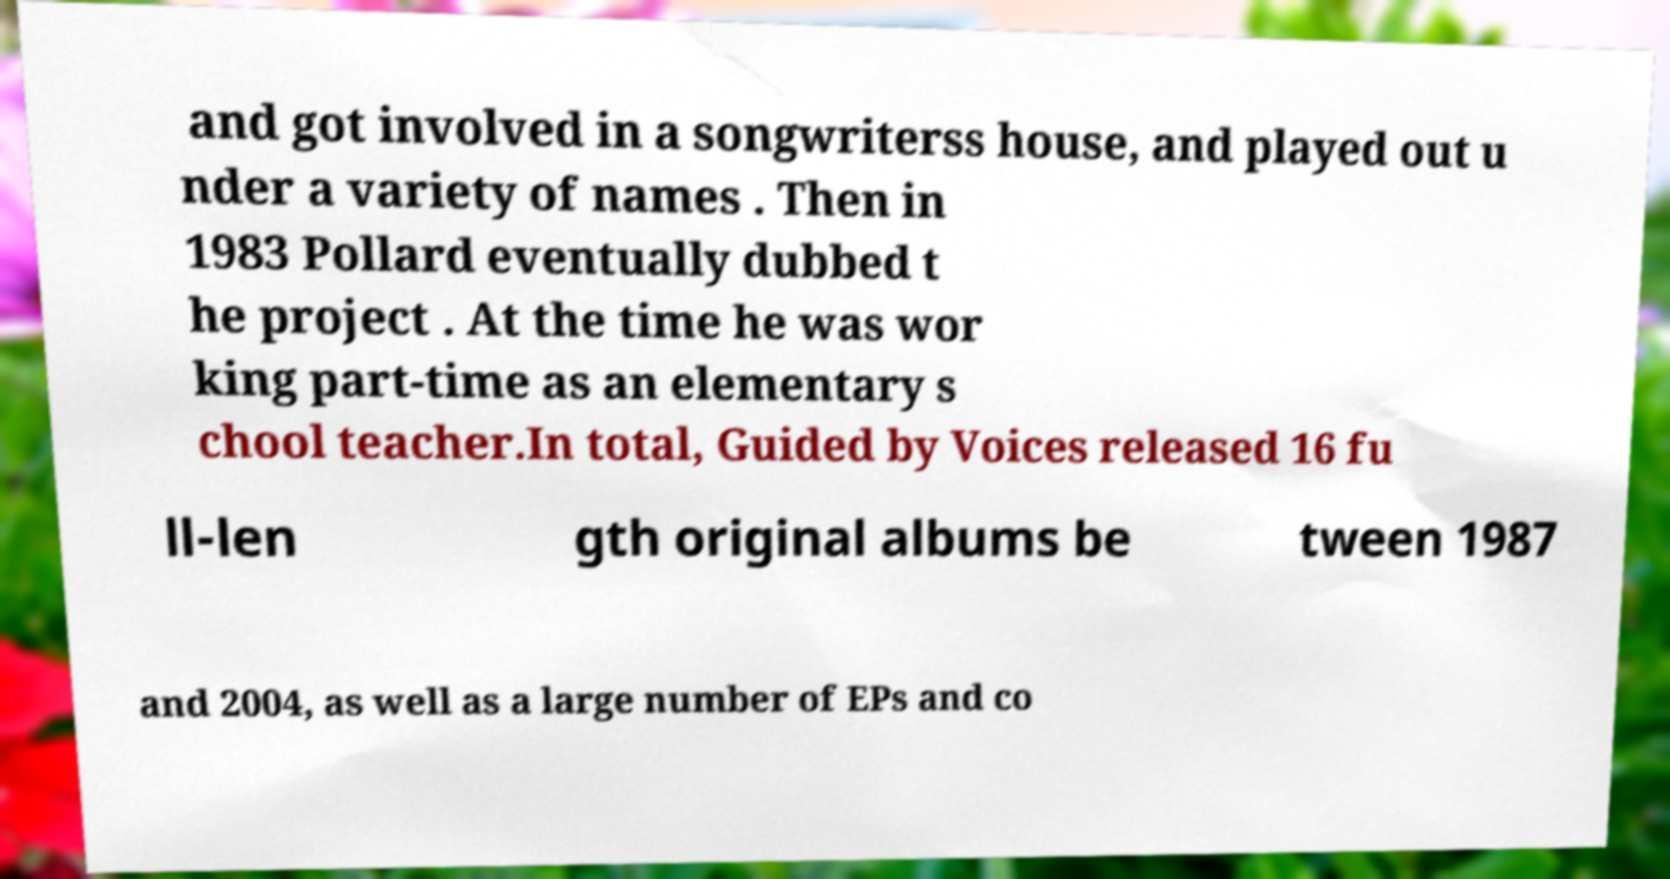What messages or text are displayed in this image? I need them in a readable, typed format. and got involved in a songwriterss house, and played out u nder a variety of names . Then in 1983 Pollard eventually dubbed t he project . At the time he was wor king part-time as an elementary s chool teacher.In total, Guided by Voices released 16 fu ll-len gth original albums be tween 1987 and 2004, as well as a large number of EPs and co 